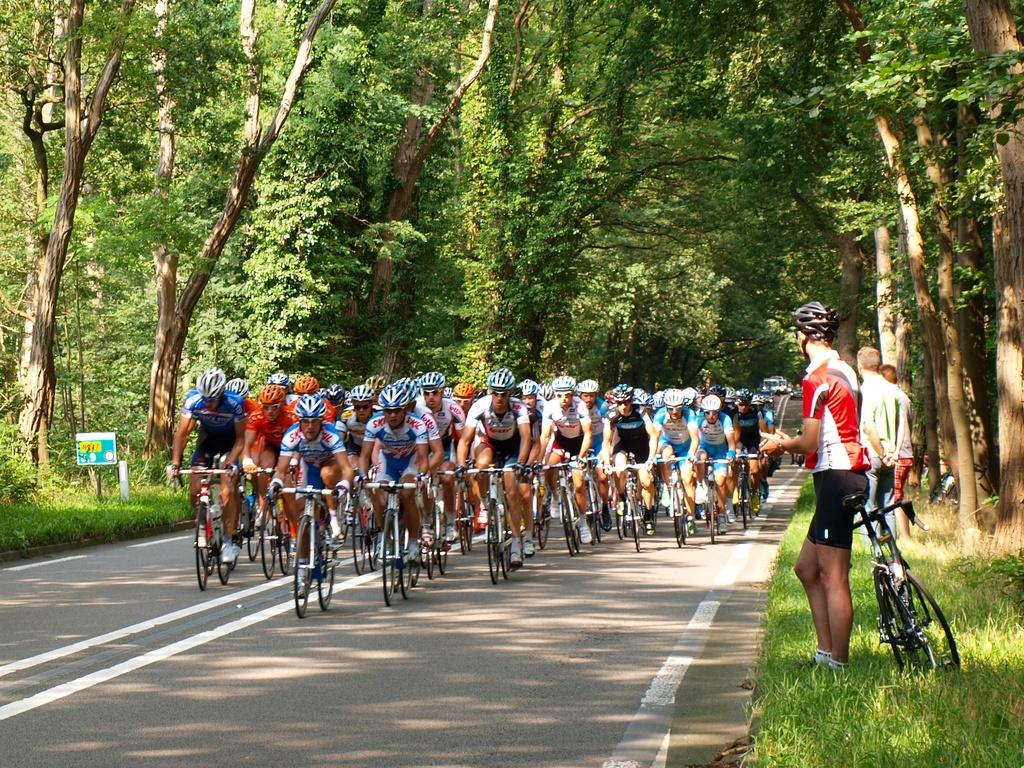Where was the image taken? The image was taken on the road. What are the people in the image doing? There are people riding bicycles on the road, and there are people standing on the right side of the road. What can be seen in the image besides the people? There is a bicycle in the image. What is visible in the background of the image? There are trees in the background of the image. Can you see a beam of light shining on the people riding bicycles in the image? There is no beam of light visible in the image; it only shows people riding bicycles and standing on the road. What type of kite is being flown by the people standing on the right side of the road? There is no kite present in the image; it only shows people standing on the right side of the road. 